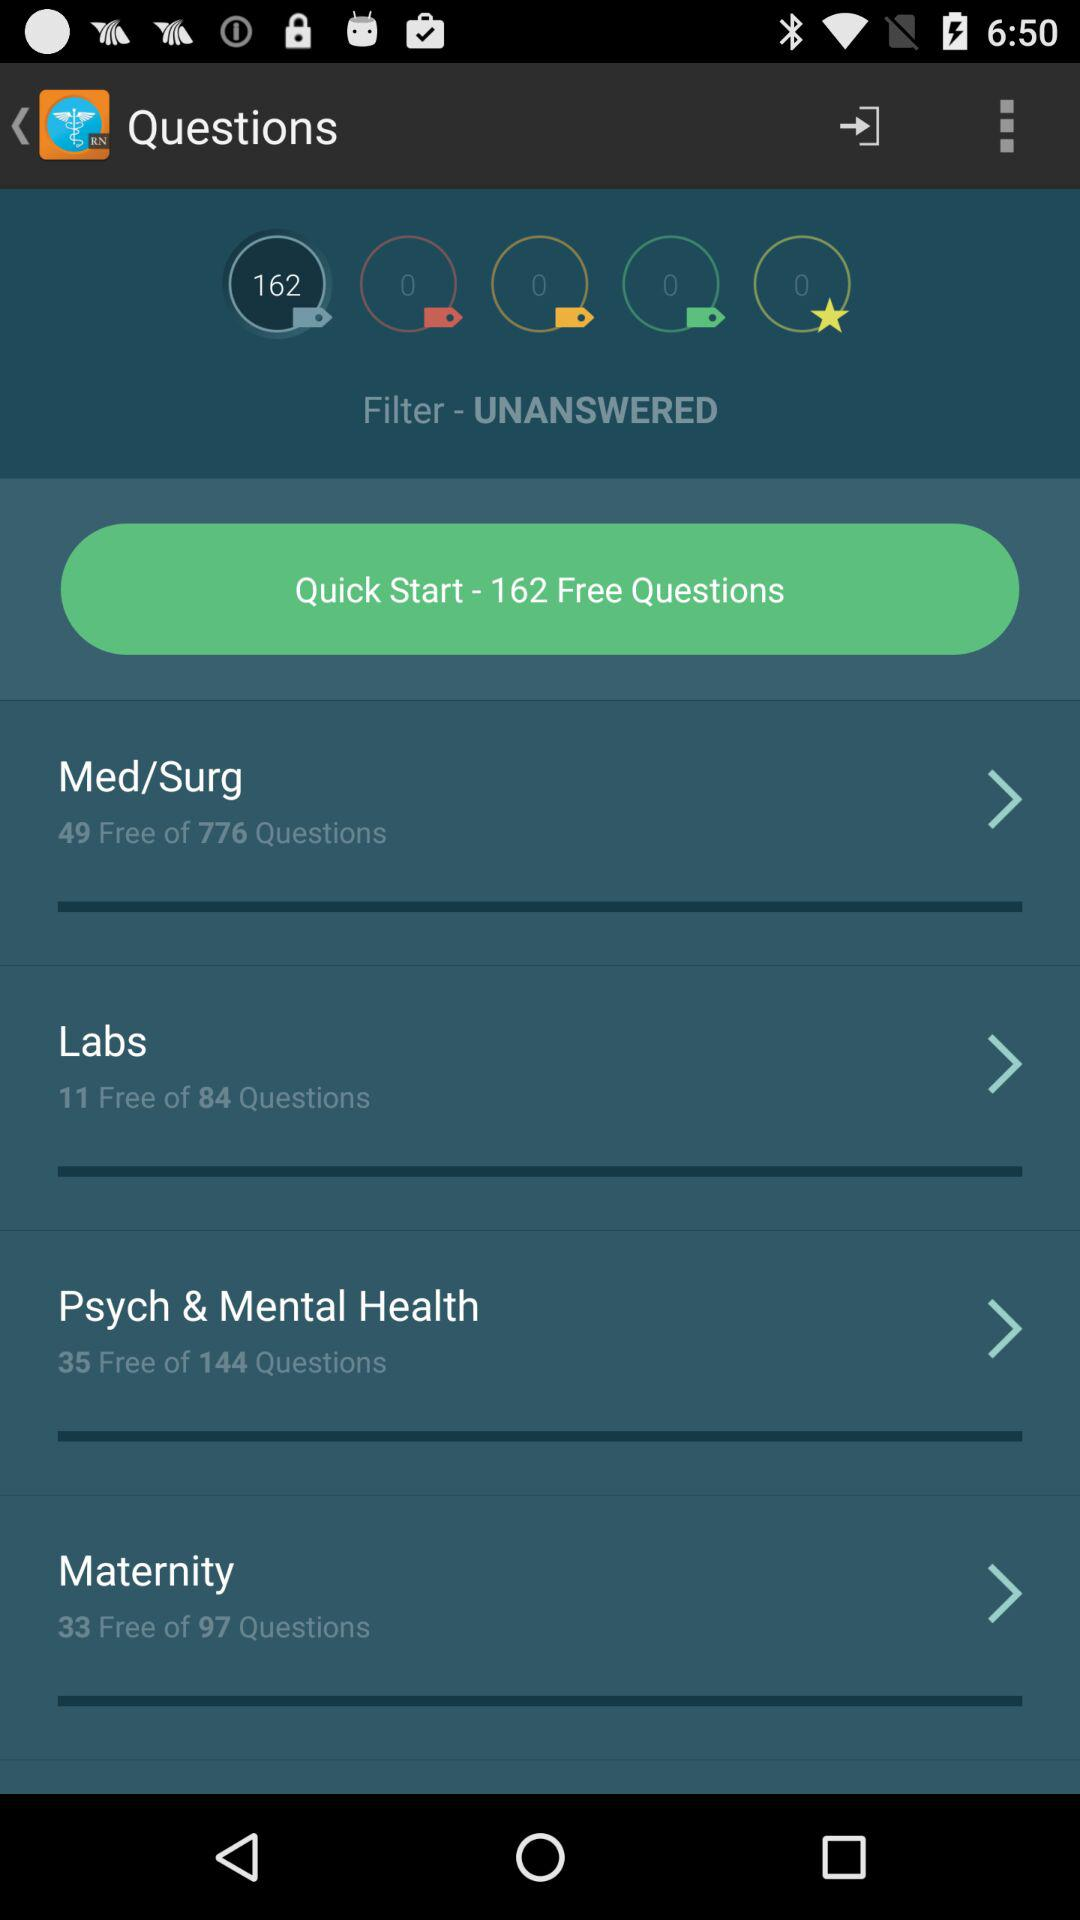What is the total number of questions in "Maternity"? The total number of questions in "Maternity" is 97. 